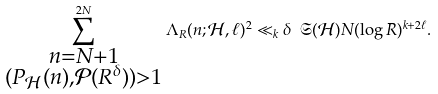Convert formula to latex. <formula><loc_0><loc_0><loc_500><loc_500>\sum _ { \substack { n = N + 1 \\ ( P _ { \mathcal { H } } ( n ) , \mathcal { P } ( R ^ { \delta } ) ) > 1 } } ^ { 2 N } \Lambda _ { R } ( n ; \mathcal { H } , \ell ) ^ { 2 } \ll _ { k } \delta \ \mathfrak S ( \mathcal { H } ) N ( \log R ) ^ { k + 2 \ell } .</formula> 